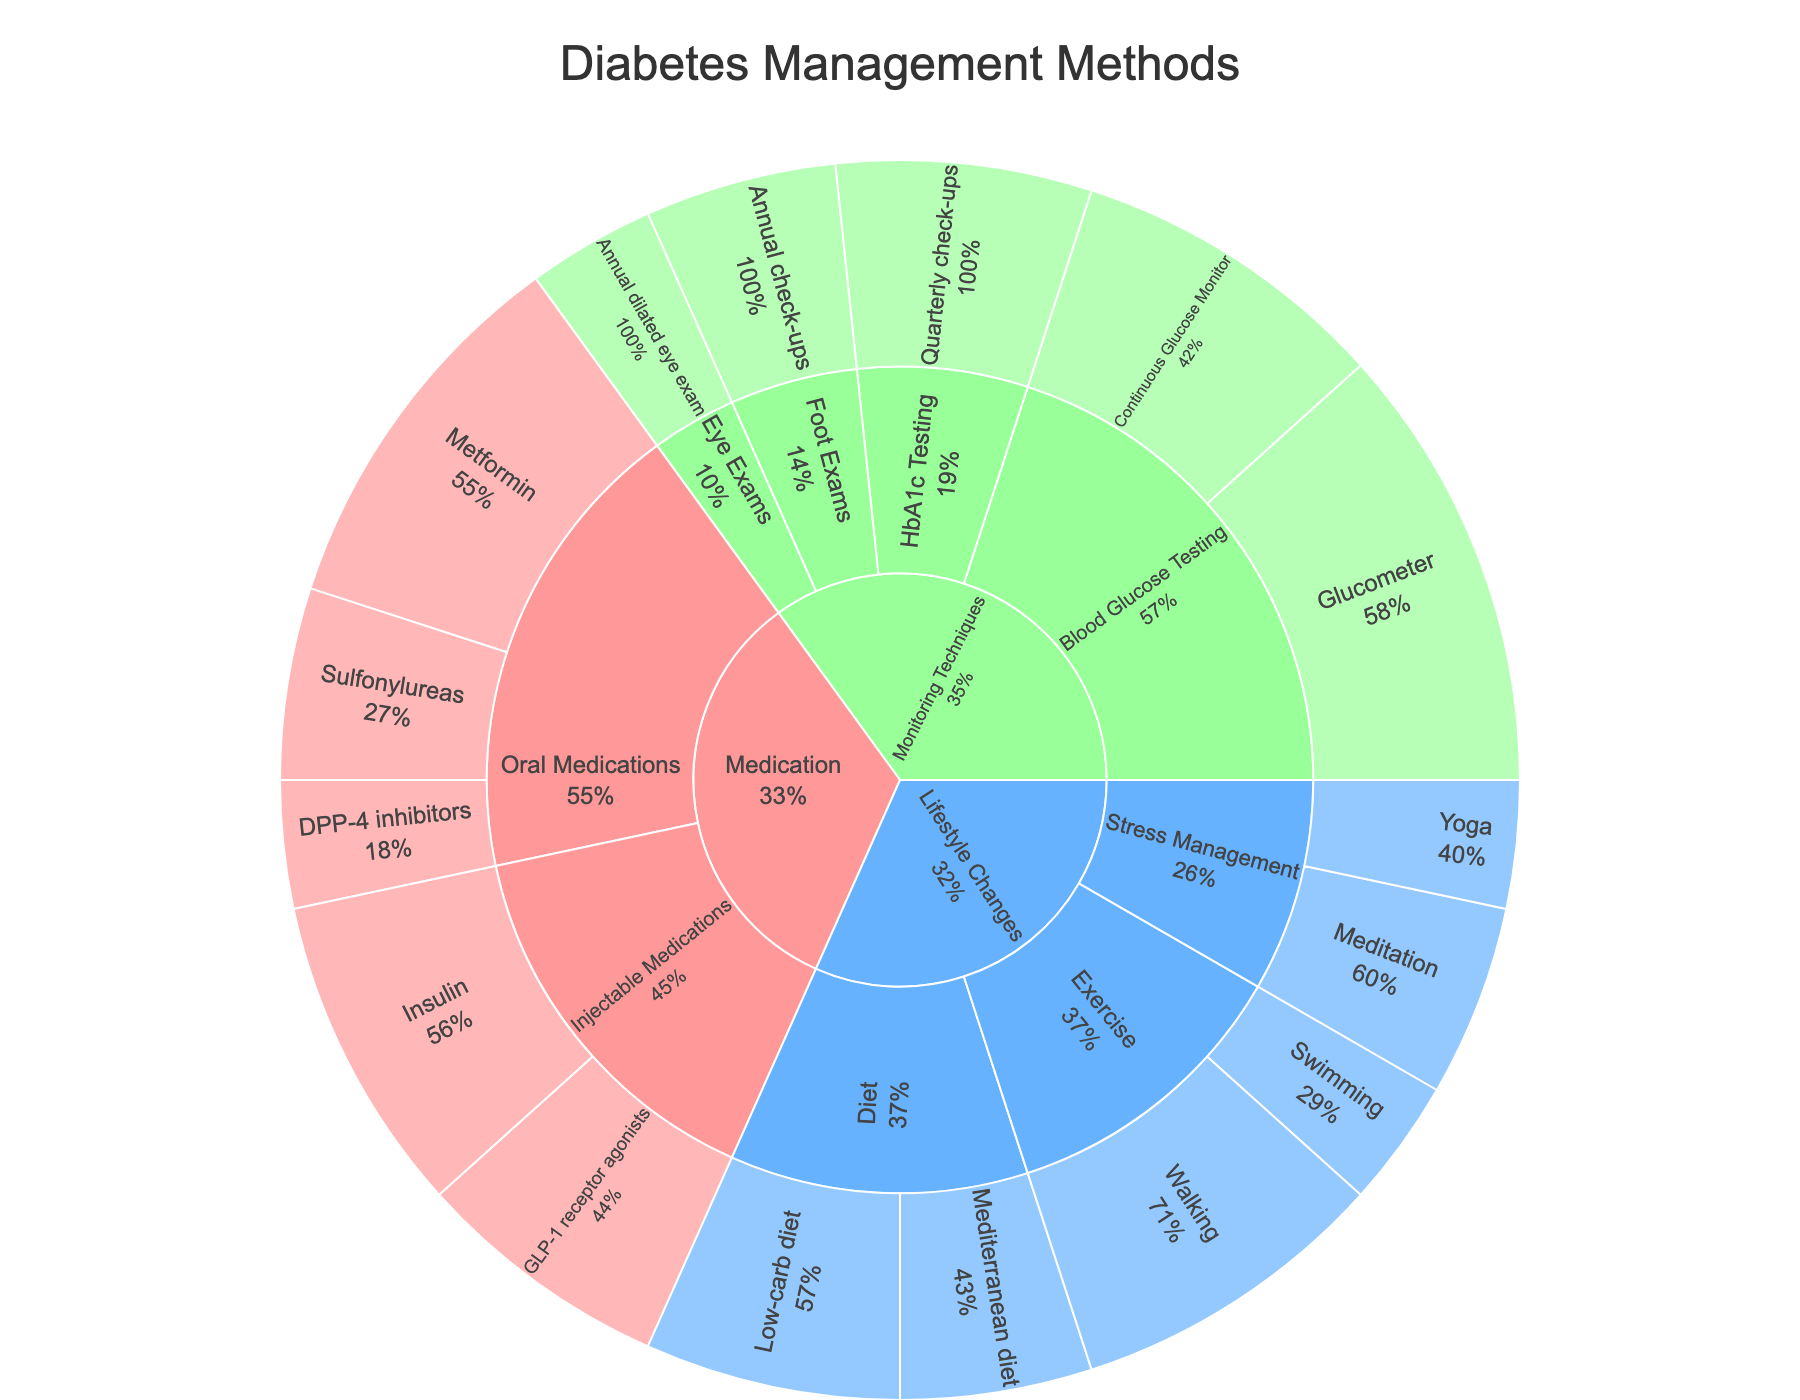What's the largest category represented in the Sunburst Plot? The largest category can be identified by looking for the outermost ring segment that has the largest area or the highest percentage value in the chart. In this case, Medication appears to be the largest.
Answer: Medication How much of the overall value is contributed by the Glucometer under Blood Glucose Testing? Locate the segment for Glucometer under Blood Glucose Testing in the Monitoring Techniques category. It shows a value of 35.
Answer: 35 Which subcategory of Medication has a higher value, Oral Medications or Injectable Medications? Check the segments for Oral Medications and Injectable Medications within the Medication category to compare their values. Oral Medications (55) has a higher value than Injectable Medications (45).
Answer: Oral Medications What is the combined value of all the exercise-related methods? Sum the values of Walking and Swimming under the Exercise subcategory of Lifestyle Changes (25 + 10 = 35).
Answer: 35 Among Medication and Lifestyle Changes, which category has more diversification in its subcategories? Compare the number of subcategories under Medication (Oral Medications, Injectable Medications) and Lifestyle Changes (Diet, Exercise, Stress Management). Lifestyle Changes has more subcategories.
Answer: Lifestyle Changes What is the proportion of Insulin's value relative to the total value of Injectable Medications? Divide the value of Insulin (25) by the total value of Injectable Medications (25 + 20 = 45) and then multiply by 100 to get the percentage (25 / 45 * 100 ≈ 55.56%).
Answer: ~55.6% Which monitoring technique has the least value and how much is it? Find the Monitoring Techniques category and identify the technique with the smallest segment, which is the Annual dilated eye exam with a value of 10.
Answer: Annual dilated eye exam, 10 What's the total value for all the elements in the Diet subcategory? Add the values of Low-carb diet and Mediterranean diet under the Diet subcategory of Lifestyle Changes (20 + 15 = 35).
Answer: 35 Is the value of Quarterly check-ups for HbA1c Testing higher than the total value of all Stress Management techniques? Compare the value of Quarterly check-ups (20) with the sum of Meditation and Yoga under Stress Management (15 + 10 = 25). The total for Stress Management is higher.
Answer: No 